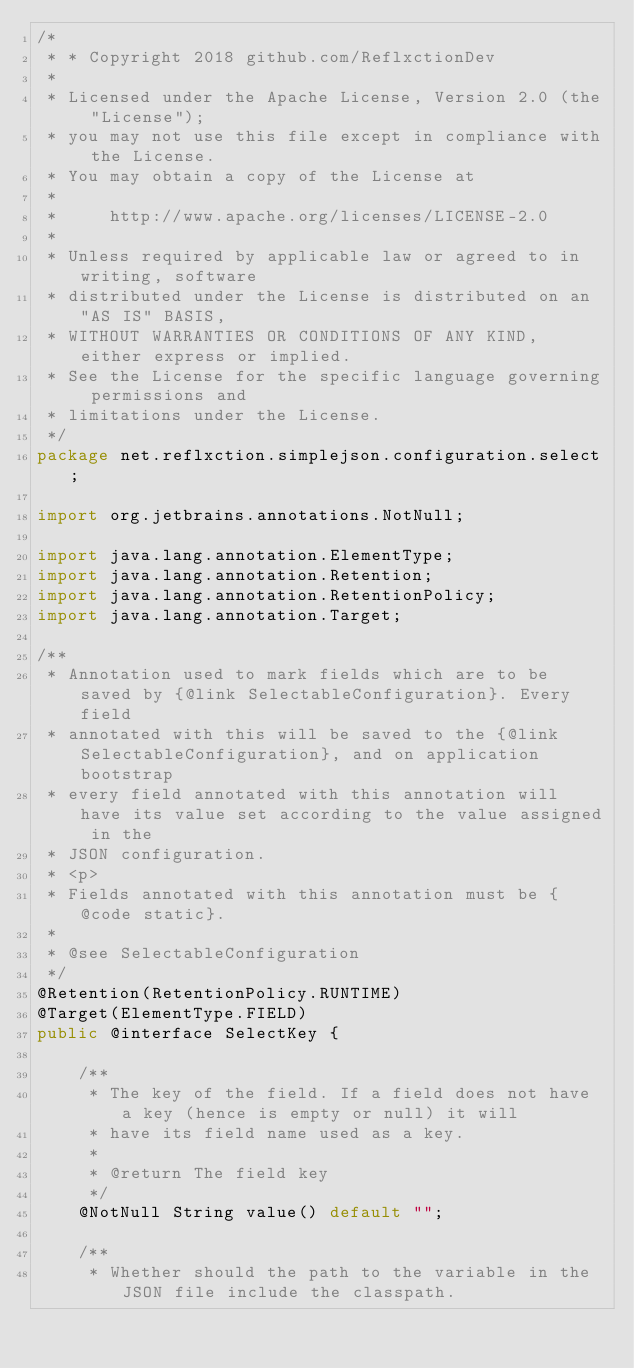<code> <loc_0><loc_0><loc_500><loc_500><_Java_>/*
 * * Copyright 2018 github.com/ReflxctionDev
 *
 * Licensed under the Apache License, Version 2.0 (the "License");
 * you may not use this file except in compliance with the License.
 * You may obtain a copy of the License at
 *
 *     http://www.apache.org/licenses/LICENSE-2.0
 *
 * Unless required by applicable law or agreed to in writing, software
 * distributed under the License is distributed on an "AS IS" BASIS,
 * WITHOUT WARRANTIES OR CONDITIONS OF ANY KIND, either express or implied.
 * See the License for the specific language governing permissions and
 * limitations under the License.
 */
package net.reflxction.simplejson.configuration.select;

import org.jetbrains.annotations.NotNull;

import java.lang.annotation.ElementType;
import java.lang.annotation.Retention;
import java.lang.annotation.RetentionPolicy;
import java.lang.annotation.Target;

/**
 * Annotation used to mark fields which are to be saved by {@link SelectableConfiguration}. Every field
 * annotated with this will be saved to the {@link SelectableConfiguration}, and on application bootstrap
 * every field annotated with this annotation will have its value set according to the value assigned in the
 * JSON configuration.
 * <p>
 * Fields annotated with this annotation must be {@code static}.
 *
 * @see SelectableConfiguration
 */
@Retention(RetentionPolicy.RUNTIME)
@Target(ElementType.FIELD)
public @interface SelectKey {

    /**
     * The key of the field. If a field does not have a key (hence is empty or null) it will
     * have its field name used as a key.
     *
     * @return The field key
     */
    @NotNull String value() default "";

    /**
     * Whether should the path to the variable in the JSON file include the classpath.</code> 